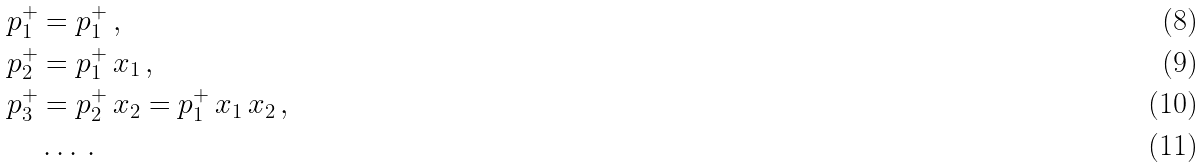<formula> <loc_0><loc_0><loc_500><loc_500>p _ { 1 } ^ { + } & = p _ { 1 } ^ { + } \, , \\ p _ { 2 } ^ { + } & = p _ { 1 } ^ { + } \, x _ { 1 } \, , \\ p _ { 3 } ^ { + } & = p _ { 2 } ^ { + } \, x _ { 2 } = p _ { 1 } ^ { + } \, x _ { 1 } \, x _ { 2 } \, , \\ & \dots \, .</formula> 